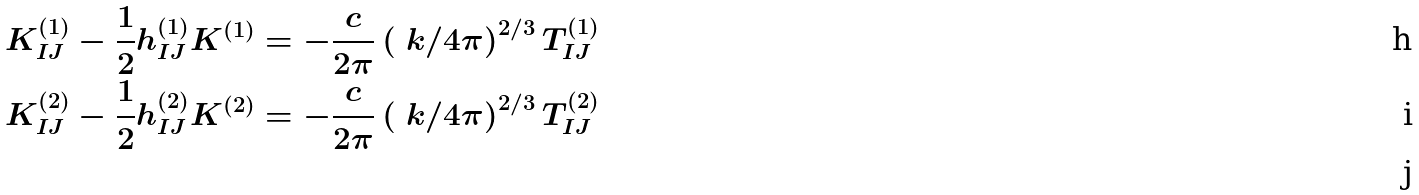<formula> <loc_0><loc_0><loc_500><loc_500>K ^ { ( 1 ) } _ { I J } - \frac { 1 } { 2 } h ^ { ( 1 ) } _ { I J } K ^ { ( 1 ) } & = - \frac { c } { 2 \pi } \left ( \ k / 4 \pi \right ) ^ { 2 / 3 } T ^ { ( 1 ) } _ { I J } \\ K ^ { ( 2 ) } _ { I J } - \frac { 1 } { 2 } h ^ { ( 2 ) } _ { I J } K ^ { ( 2 ) } & = - \frac { c } { 2 \pi } \left ( \ k / 4 \pi \right ) ^ { 2 / 3 } T ^ { ( 2 ) } _ { I J } \\</formula> 